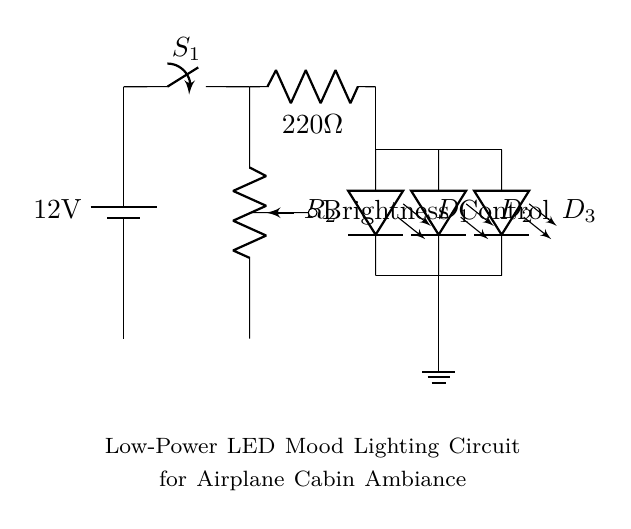What is the voltage of the power supply in this circuit? The power supply is labeled with a voltage of 12 volts, marked clearly on the battery in the diagram.
Answer: 12 volts What is the function of the resistor labeled R1? Resistor R1 is a current limiting resistor. It is connected in series with the LEDs to control the amount of current flowing through them to prevent damage.
Answer: Current limiting How many LEDs are used in this circuit? The diagram displays three LEDs, labeled as D1, D2, and D3, indicating their presence and distinct labeling in parallel configuration.
Answer: Three What component is used to control brightness? There is a potentiometer labeled R2, which functions as a variable resistor to adjust the brightness of the LEDs, shown connected before the switch.
Answer: Potentiometer What is the total current flow path for the LEDs? The current flows from the battery through the switch S1, passes R1, and then splits into three paths for each LED before returning to the ground. The brightness control potentiometer also affects this path.
Answer: Battery to switch to resistor to LEDs to ground What is the purpose of the switch S1 in the circuit? The switch S1 is utilized to control the ON/OFF state of the circuit, allowing the user to easily turn the mood lighting on or off as needed.
Answer: ON/OFF control 